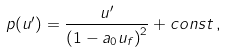Convert formula to latex. <formula><loc_0><loc_0><loc_500><loc_500>p ( u ^ { \prime } ) = \frac { u ^ { \prime } } { { ( 1 - a _ { 0 } u _ { f } ) } ^ { 2 } } + c o n s t \, ,</formula> 